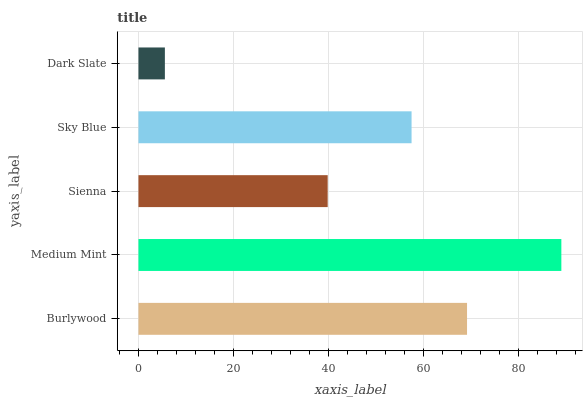Is Dark Slate the minimum?
Answer yes or no. Yes. Is Medium Mint the maximum?
Answer yes or no. Yes. Is Sienna the minimum?
Answer yes or no. No. Is Sienna the maximum?
Answer yes or no. No. Is Medium Mint greater than Sienna?
Answer yes or no. Yes. Is Sienna less than Medium Mint?
Answer yes or no. Yes. Is Sienna greater than Medium Mint?
Answer yes or no. No. Is Medium Mint less than Sienna?
Answer yes or no. No. Is Sky Blue the high median?
Answer yes or no. Yes. Is Sky Blue the low median?
Answer yes or no. Yes. Is Medium Mint the high median?
Answer yes or no. No. Is Dark Slate the low median?
Answer yes or no. No. 